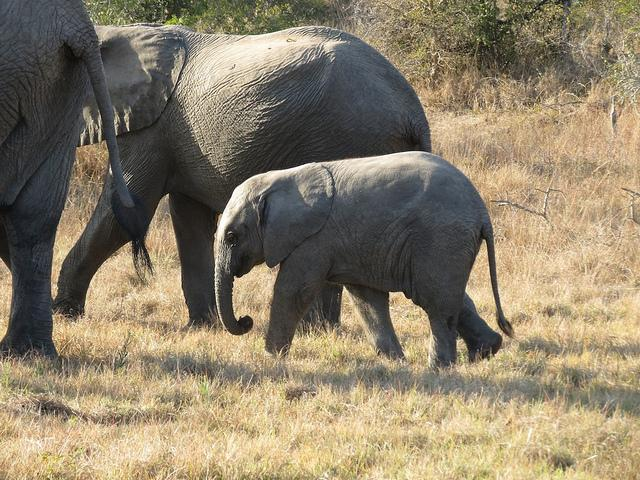How many little elephants are following behind the big elephant to the left?

Choices:
A) one
B) five
C) four
D) two two 